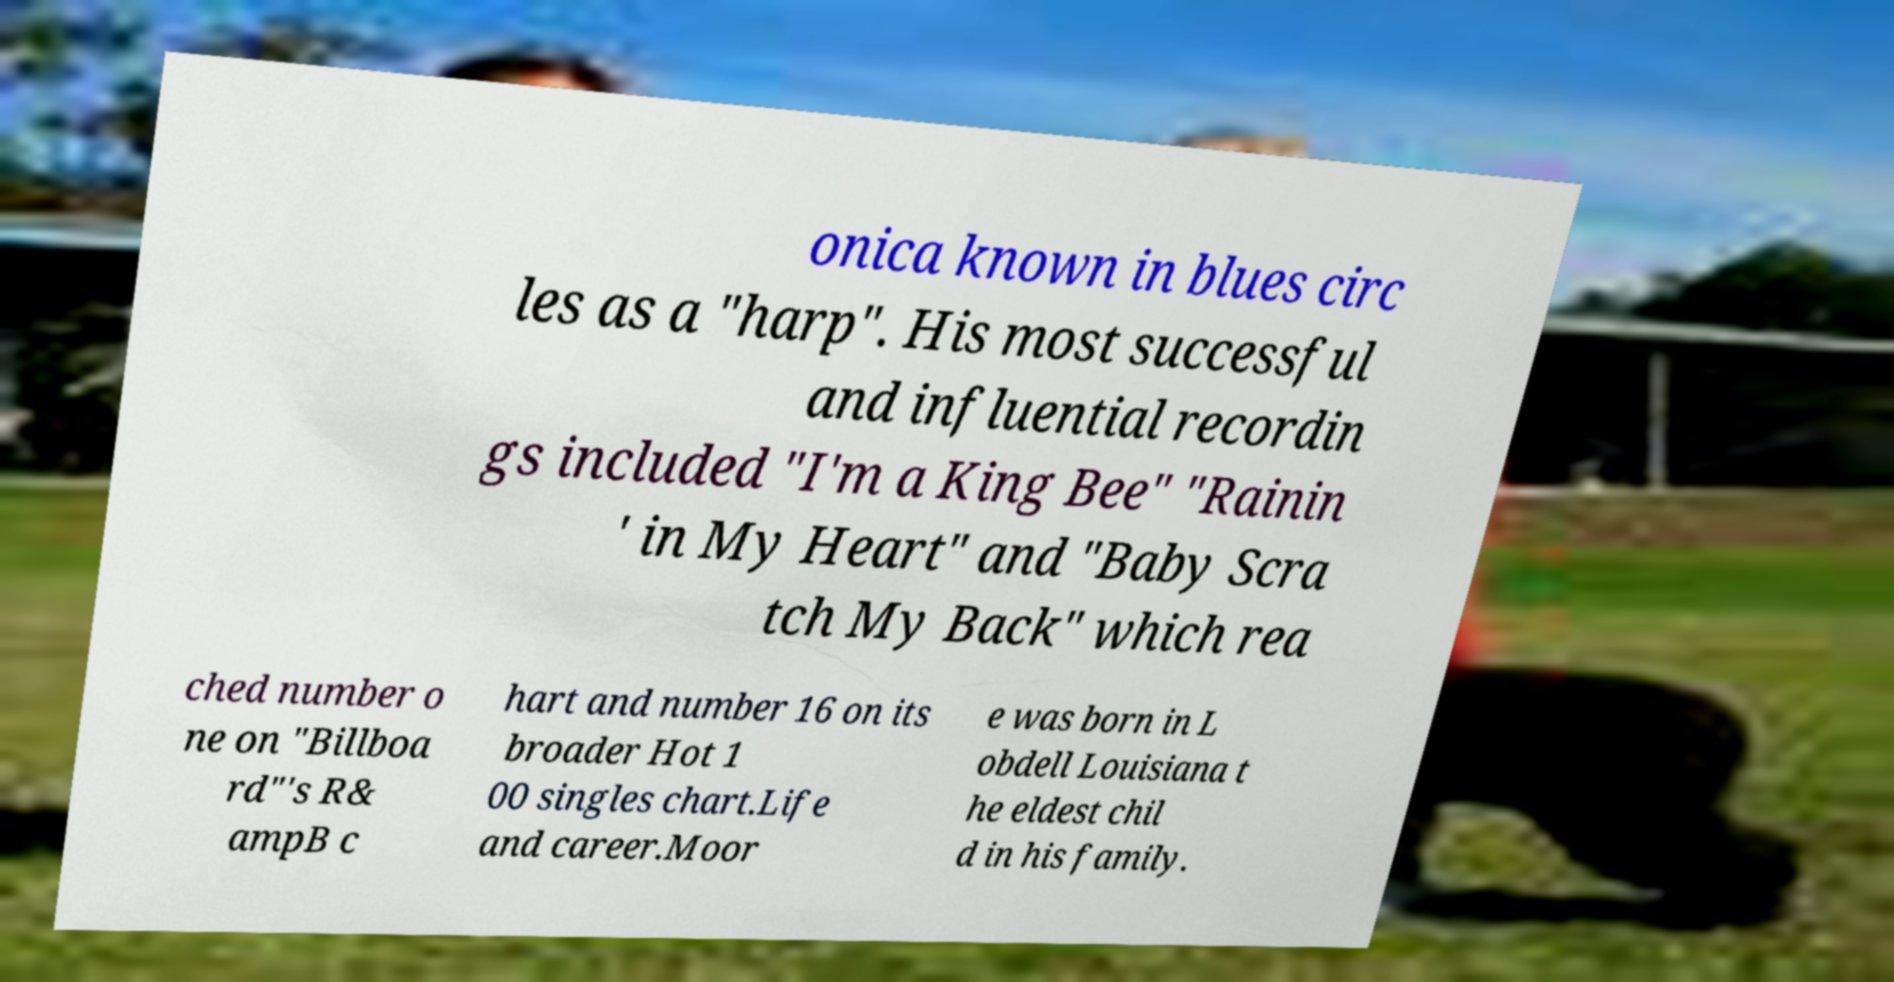Please read and relay the text visible in this image. What does it say? onica known in blues circ les as a "harp". His most successful and influential recordin gs included "I'm a King Bee" "Rainin ' in My Heart" and "Baby Scra tch My Back" which rea ched number o ne on "Billboa rd"'s R& ampB c hart and number 16 on its broader Hot 1 00 singles chart.Life and career.Moor e was born in L obdell Louisiana t he eldest chil d in his family. 